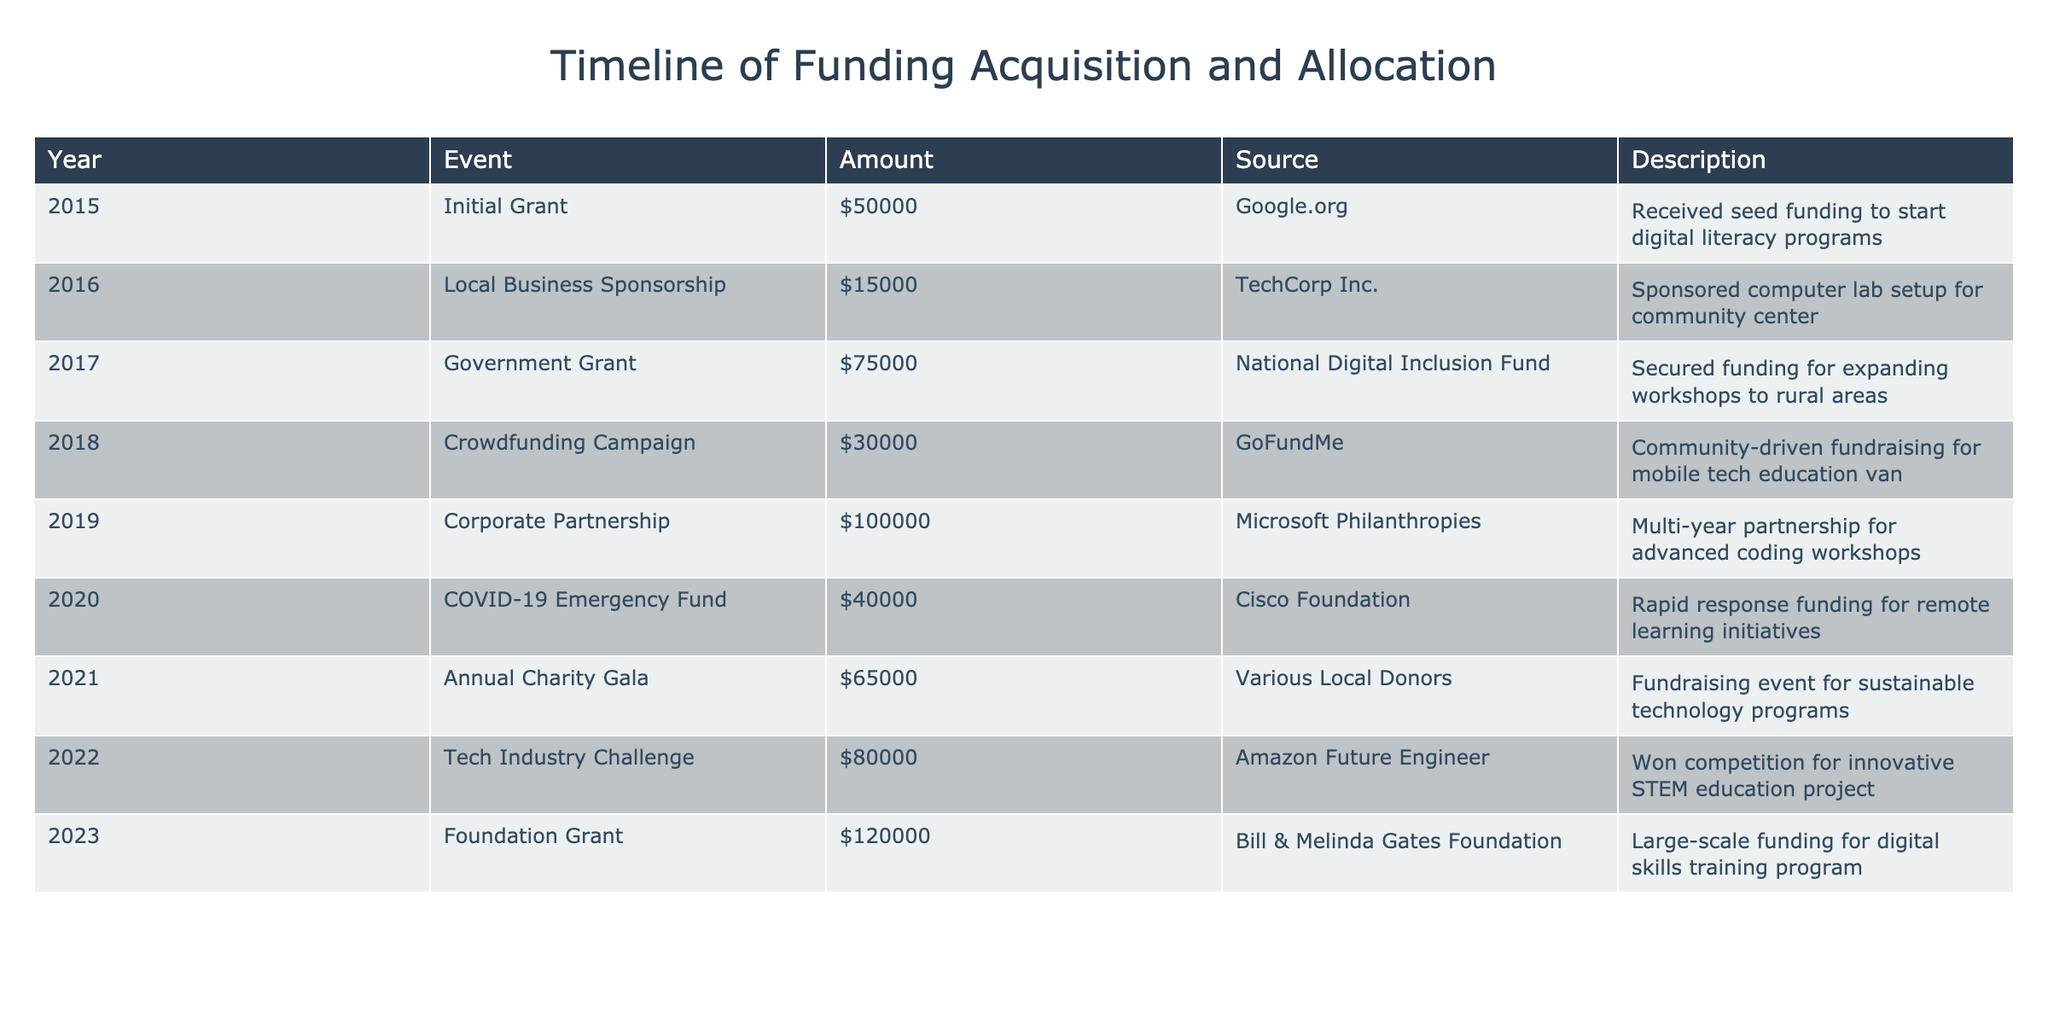What was the total amount of funding acquired in 2019? In 2019, the table lists one funding source of $100,000 from Microsoft Philanthropies. Therefore, the total amount for that year is simply $100,000.
Answer: 100000 Which year saw the highest amount of funding, and how much was it? The year 2023 shows the highest funding amount of $120,000 from the Bill & Melinda Gates Foundation. Checking other years, no amount exceeds this value.
Answer: 2023, 120000 What was the average funding amount acquired per year from 2015 to 2023? The total funding from 2015 to 2023 is $50000 + $15000 + $75000 + $30000 + $100000 + $40000 + $65000 + $80000 + $120000 = $490000. There are 9 years, so the average is $490000 / 9 ≈ $54444.44.
Answer: 54444.44 Did the total funding acquired in 2016 and 2017 exceed $100,000? The funding for 2016 is $15,000, and for 2017 it is $75,000. Adding these amounts: $15,000 + $75,000 = $90,000, which does not exceed $100,000.
Answer: No What funding source was used to support remote learning initiatives, and how much was it? The COVID-19 Emergency Fund in 2020, provided by the Cisco Foundation, supported remote learning initiatives with a funding amount of $40,000, specifically indicated in the table.
Answer: Cisco Foundation, 40000 How much funding did the organization receive from corporate partnerships between 2015 and 2023? The organization received $100,000 from a corporate partnership in 2019 (Microsoft Philanthropies). There are no other corporate partnerships mentioned in the data, making the total $100,000.
Answer: 100000 Which event in the timeline involved community-driven fundraising, and what was the amount? The Crowdfunding Campaign in 2018 involved community-driven fundraising and garnered $30,000 as noted in the description.
Answer: Crowdfunding Campaign, 30000 Calculate the difference in funding amounts between the events with the lowest and highest amounts. The lowest funding amount listed is $15,000 from the Local Business Sponsorship in 2016. The highest is $120,000 from the Foundation Grant in 2023. The difference is $120,000 - $15,000 = $105,000.
Answer: 105000 